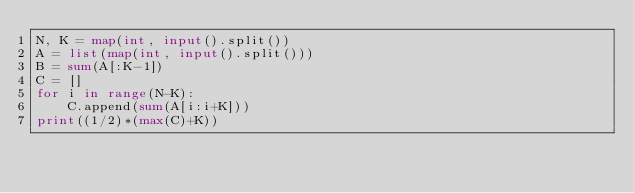<code> <loc_0><loc_0><loc_500><loc_500><_Python_>N, K = map(int, input().split())
A = list(map(int, input().split()))
B = sum(A[:K-1])
C = []
for i in range(N-K):
    C.append(sum(A[i:i+K]))
print((1/2)*(max(C)+K))</code> 